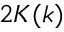<formula> <loc_0><loc_0><loc_500><loc_500>2 K ( k )</formula> 